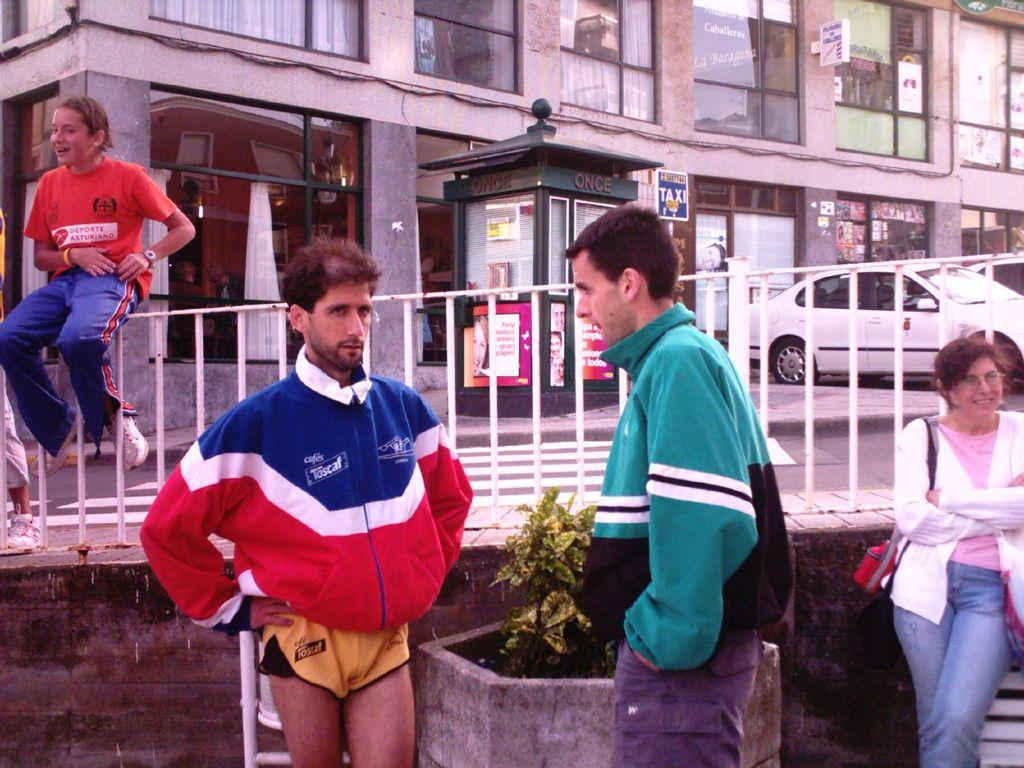Provide a one-sentence caption for the provided image. A man wearing a red white and blue jacket with a Toscaf logo printed on front. 